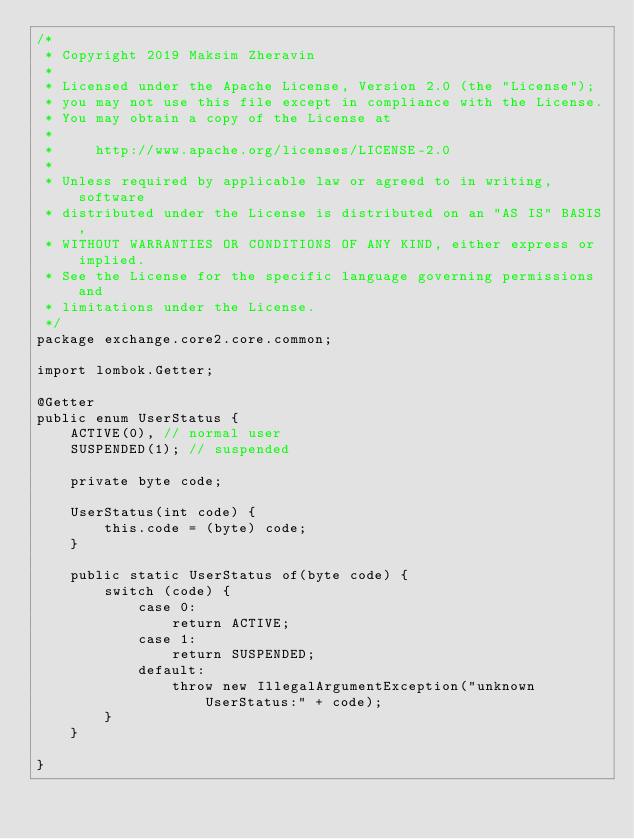Convert code to text. <code><loc_0><loc_0><loc_500><loc_500><_Java_>/*
 * Copyright 2019 Maksim Zheravin
 *
 * Licensed under the Apache License, Version 2.0 (the "License");
 * you may not use this file except in compliance with the License.
 * You may obtain a copy of the License at
 *
 *     http://www.apache.org/licenses/LICENSE-2.0
 *
 * Unless required by applicable law or agreed to in writing, software
 * distributed under the License is distributed on an "AS IS" BASIS,
 * WITHOUT WARRANTIES OR CONDITIONS OF ANY KIND, either express or implied.
 * See the License for the specific language governing permissions and
 * limitations under the License.
 */
package exchange.core2.core.common;

import lombok.Getter;

@Getter
public enum UserStatus {
    ACTIVE(0), // normal user
    SUSPENDED(1); // suspended

    private byte code;

    UserStatus(int code) {
        this.code = (byte) code;
    }

    public static UserStatus of(byte code) {
        switch (code) {
            case 0:
                return ACTIVE;
            case 1:
                return SUSPENDED;
            default:
                throw new IllegalArgumentException("unknown UserStatus:" + code);
        }
    }

}
</code> 